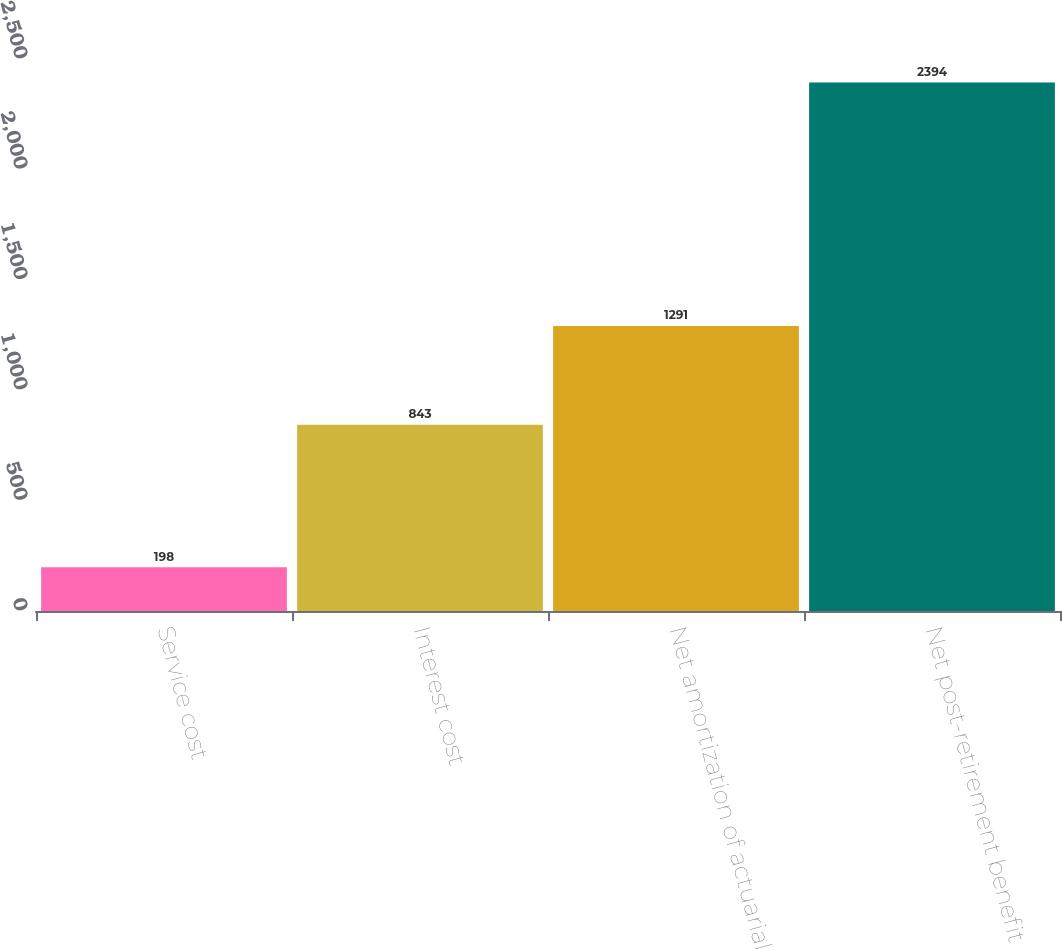Convert chart. <chart><loc_0><loc_0><loc_500><loc_500><bar_chart><fcel>Service cost<fcel>Interest cost<fcel>Net amortization of actuarial<fcel>Net post-retirement benefit<nl><fcel>198<fcel>843<fcel>1291<fcel>2394<nl></chart> 